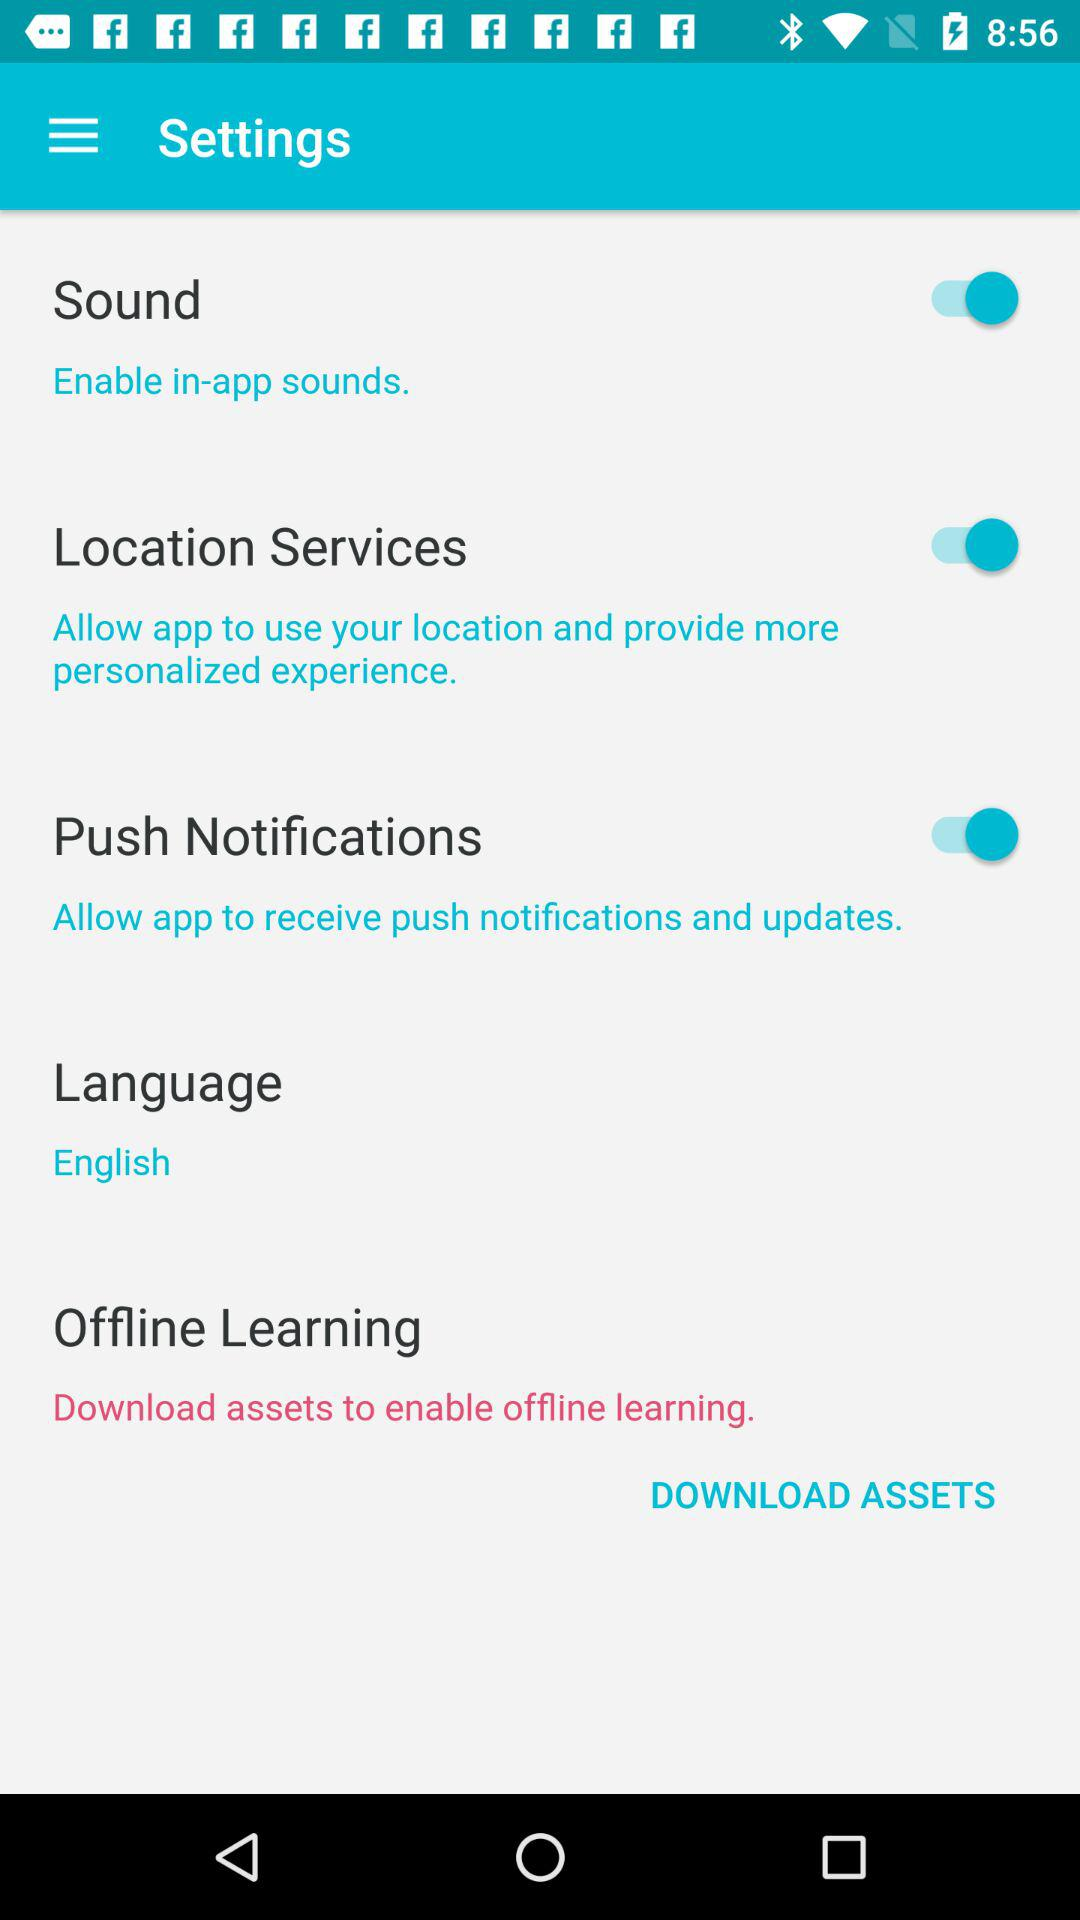What is the status of the "Push Notifications"? The status is "on". 